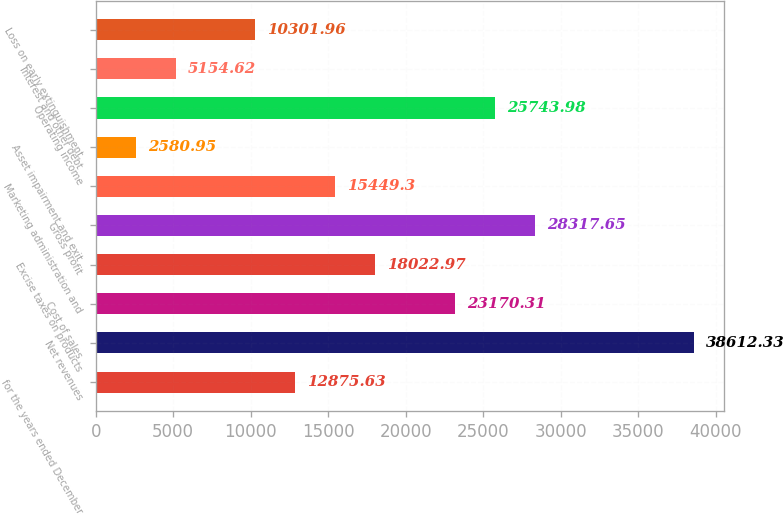<chart> <loc_0><loc_0><loc_500><loc_500><bar_chart><fcel>for the years ended December<fcel>Net revenues<fcel>Cost of sales<fcel>Excise taxes on products<fcel>Gross profit<fcel>Marketing administration and<fcel>Asset impairment and exit<fcel>Operating income<fcel>Interest and other debt<fcel>Loss on early extinguishment<nl><fcel>12875.6<fcel>38612.3<fcel>23170.3<fcel>18023<fcel>28317.7<fcel>15449.3<fcel>2580.95<fcel>25744<fcel>5154.62<fcel>10302<nl></chart> 